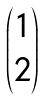Convert formula to latex. <formula><loc_0><loc_0><loc_500><loc_500>\begin{pmatrix} { 1 \\ 2 } \end{pmatrix}</formula> 